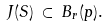Convert formula to latex. <formula><loc_0><loc_0><loc_500><loc_500>J ( S ) \, \subset \, B _ { r } ( p ) .</formula> 